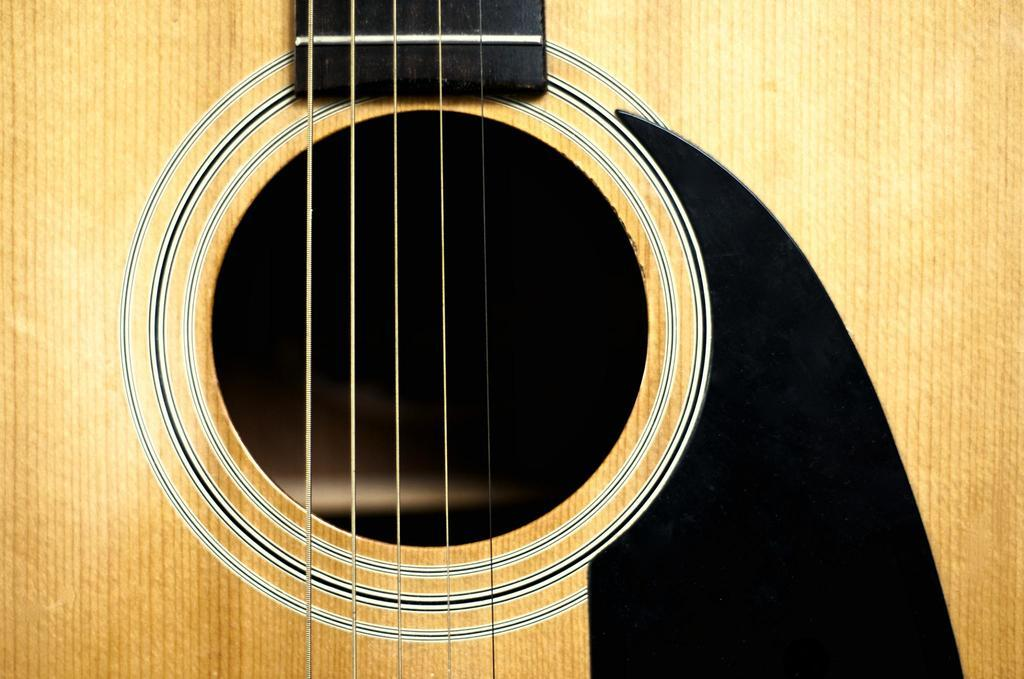What is the main subject of the image? The main subject of the image is a guitar. Can you describe the guitar in the image? Unfortunately, the image only shows the guitar, and no specific details about its appearance or type are provided. What type of skin condition can be seen on the guitar in the image? There is no skin condition present on the guitar in the image, as guitars do not have skin. 